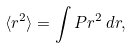Convert formula to latex. <formula><loc_0><loc_0><loc_500><loc_500>\langle r ^ { 2 } \rangle = \int P r ^ { 2 } \, d { r } ,</formula> 